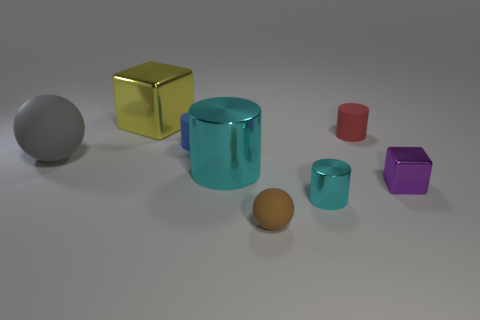Subtract all small cylinders. How many cylinders are left? 1 Subtract all cyan cylinders. How many cylinders are left? 2 Subtract all cubes. How many objects are left? 6 Subtract 2 cylinders. How many cylinders are left? 2 Add 1 big blue rubber things. How many objects exist? 9 Add 3 large cyan shiny cylinders. How many large cyan shiny cylinders are left? 4 Add 6 red matte balls. How many red matte balls exist? 6 Subtract 1 gray balls. How many objects are left? 7 Subtract all gray cylinders. Subtract all yellow cubes. How many cylinders are left? 4 Subtract all brown cylinders. How many gray balls are left? 1 